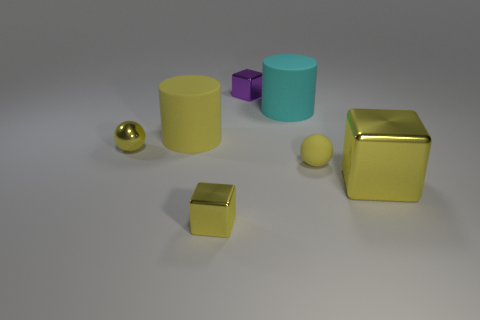Subtract all yellow cubes. How many cubes are left? 1 Subtract all purple blocks. How many blocks are left? 2 Subtract 1 cylinders. How many cylinders are left? 1 Subtract all cyan cylinders. Subtract all yellow blocks. How many cylinders are left? 1 Subtract all green cylinders. How many yellow cubes are left? 2 Subtract all purple things. Subtract all yellow blocks. How many objects are left? 4 Add 1 cyan objects. How many cyan objects are left? 2 Add 4 large metallic cubes. How many large metallic cubes exist? 5 Add 2 gray rubber balls. How many objects exist? 9 Subtract 1 yellow balls. How many objects are left? 6 